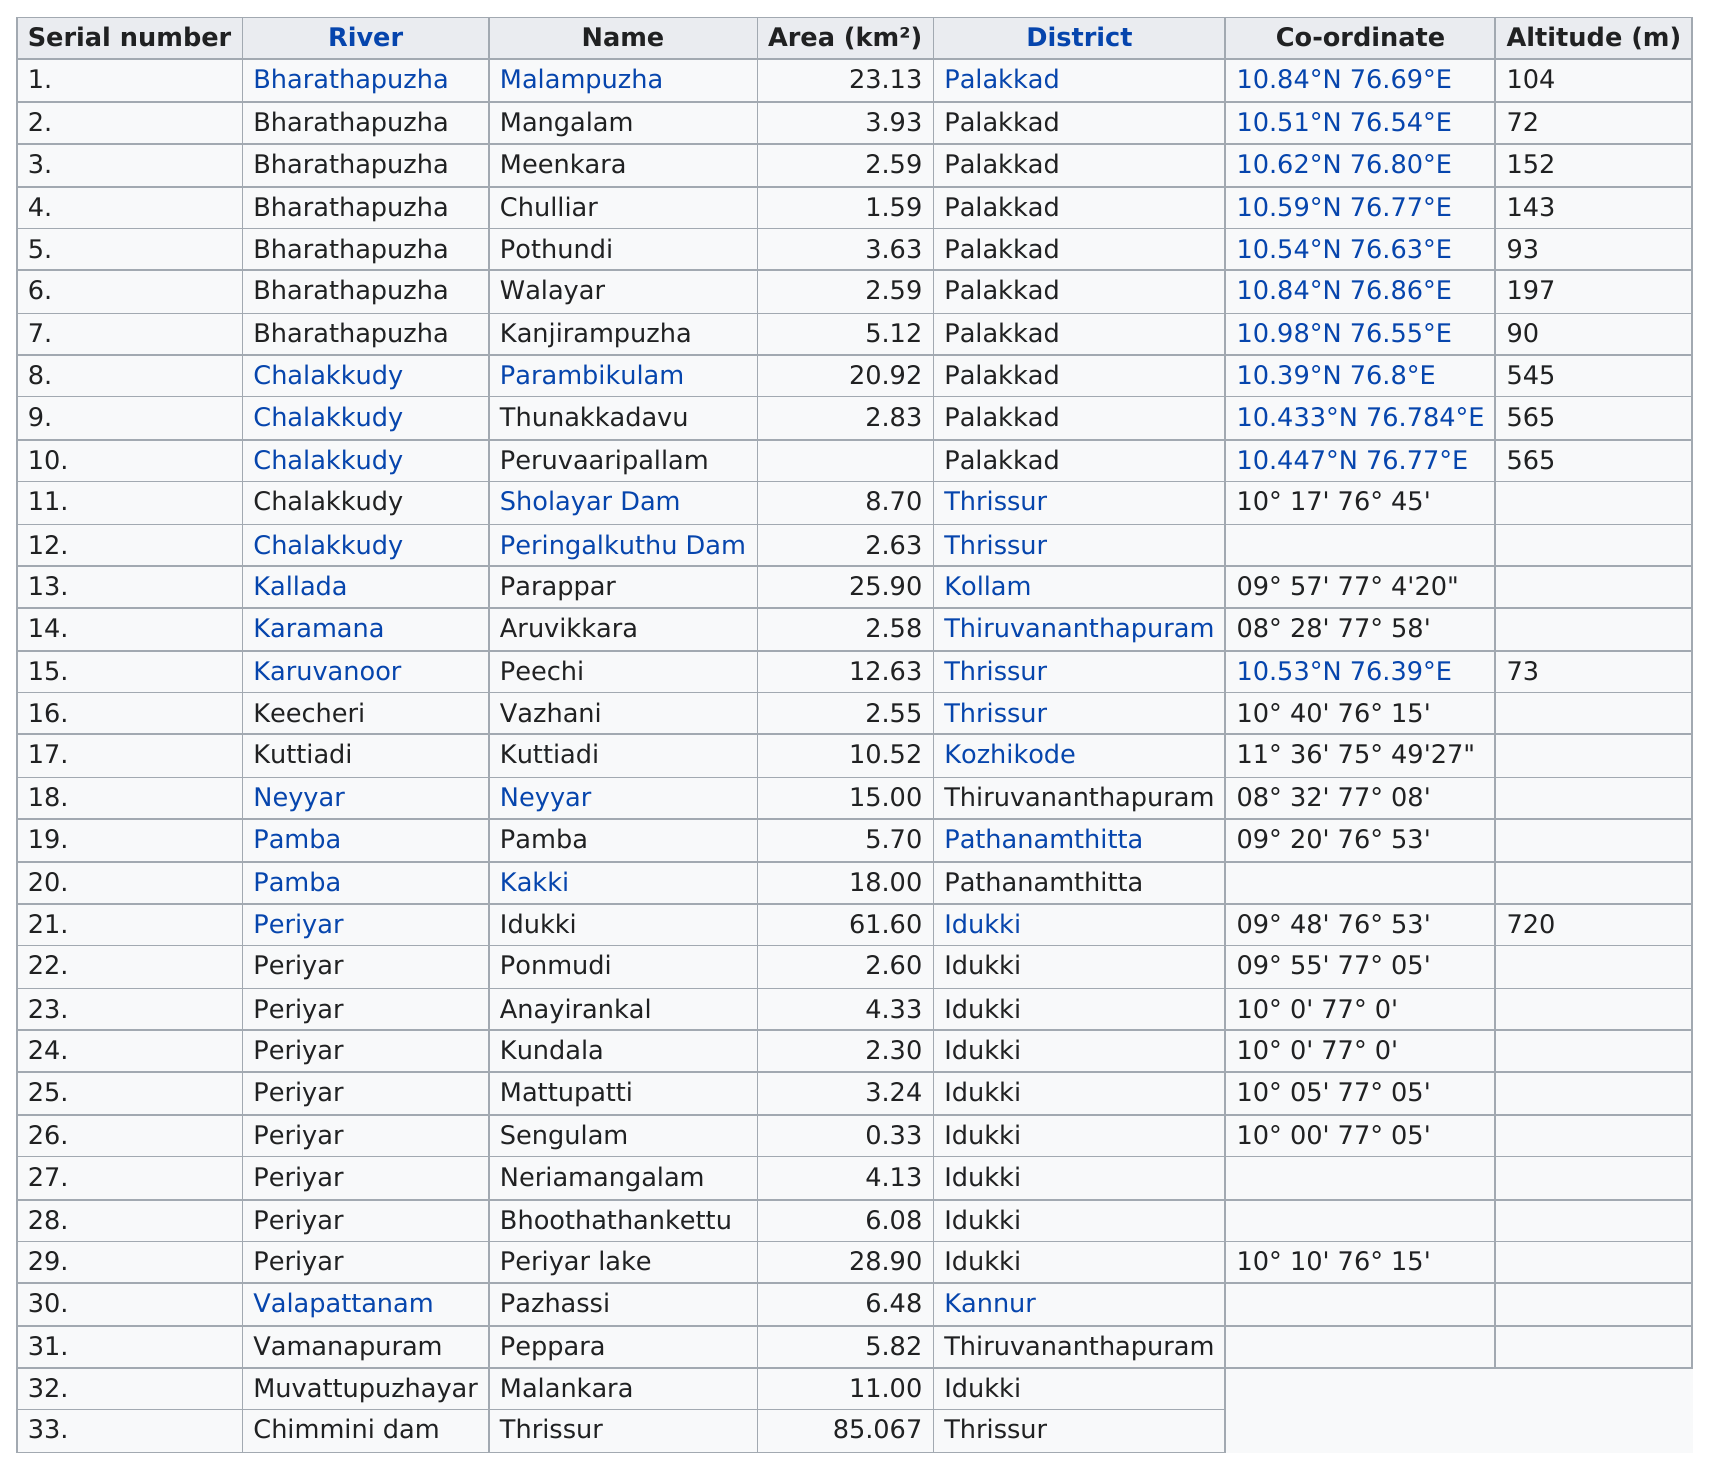Mention a couple of crucial points in this snapshot. The river before Chalakkudy is named Bharathapuzha. Valapattanam is the only reservoir in the Kannur district. I am seeking information on a reservoir that is from the same river as Parambikulam. The reservoir in question is Thunakkadavu. The Bharathapuzha river has the least altitude listed among all rivers. Malampuzha is a reservoir with an altitude of greater than 100 but less than 500. 